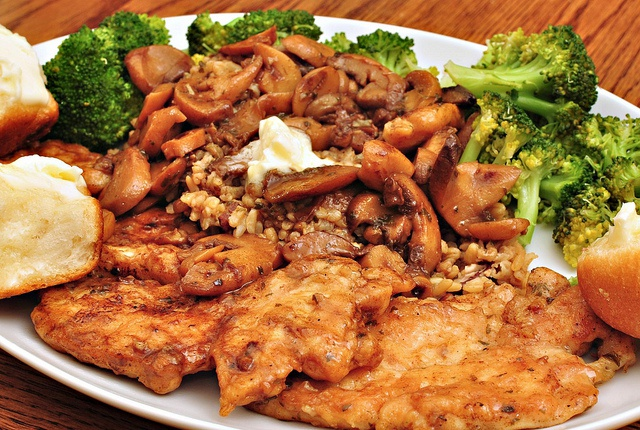Describe the objects in this image and their specific colors. I can see dining table in brown, red, orange, black, and maroon tones, broccoli in red, olive, black, and khaki tones, broccoli in red, black, darkgreen, and olive tones, broccoli in red, olive, and black tones, and broccoli in red, olive, and darkgreen tones in this image. 